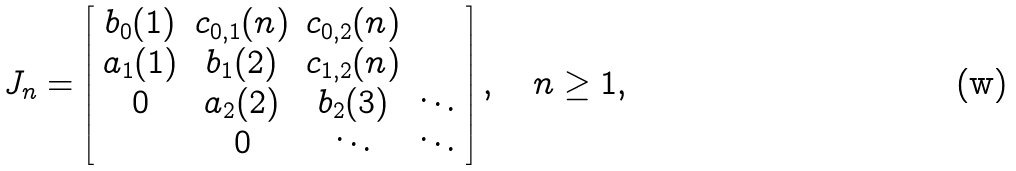<formula> <loc_0><loc_0><loc_500><loc_500>J _ { n } = \left [ \begin{array} { c c c c } b _ { 0 } ( 1 ) & c _ { 0 , 1 } ( n ) & c _ { 0 , 2 } ( n ) & \\ a _ { 1 } ( 1 ) & b _ { 1 } ( 2 ) & c _ { 1 , 2 } ( n ) & \\ 0 & a _ { 2 } ( 2 ) & b _ { 2 } ( 3 ) & \ddots \\ & 0 & \ddots & \ddots \end{array} \right ] , \quad n \geq 1 ,</formula> 